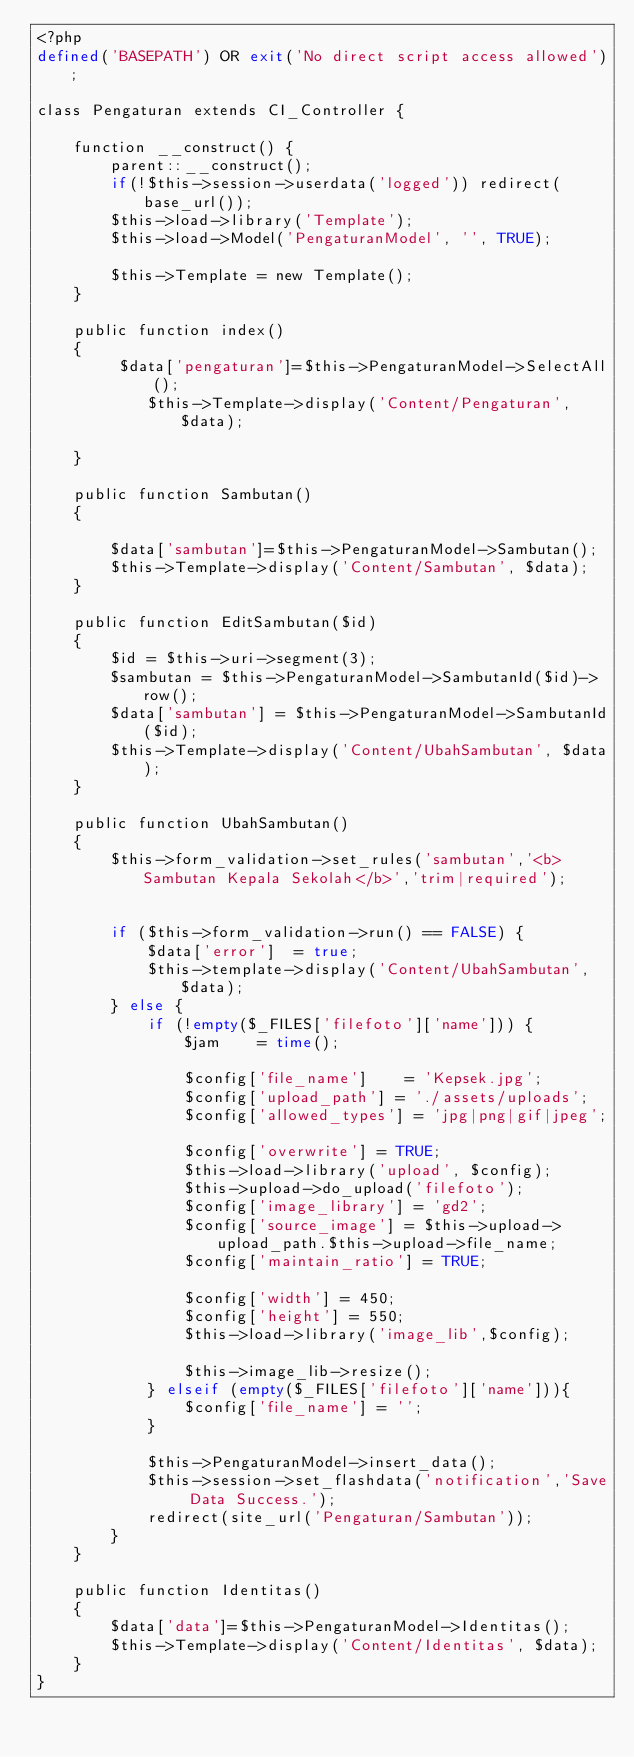Convert code to text. <code><loc_0><loc_0><loc_500><loc_500><_PHP_><?php
defined('BASEPATH') OR exit('No direct script access allowed');

class Pengaturan extends CI_Controller {

	function __construct() {
		parent::__construct(); 
		if(!$this->session->userdata('logged')) redirect(base_url());
		$this->load->library('Template');
		$this->load->Model('PengaturanModel', '', TRUE);
		
		$this->Template = new Template();
	}
	
	public function index()
	{
		 $data['pengaturan']=$this->PengaturanModel->SelectAll();
			$this->Template->display('Content/Pengaturan', $data);
		  
	}
	
	public function Sambutan()
	{
		
		$data['sambutan']=$this->PengaturanModel->Sambutan();
		$this->Template->display('Content/Sambutan', $data);
	}
	
	public function EditSambutan($id)
	{
		$id = $this->uri->segment(3);
		$sambutan = $this->PengaturanModel->SambutanId($id)->row(); 
		$data['sambutan'] = $this->PengaturanModel->SambutanId($id); 
		$this->Template->display('Content/UbahSambutan', $data);
	}
	
	public function UbahSambutan()
	{
		$this->form_validation->set_rules('sambutan','<b>Sambutan Kepala Sekolah</b>','trim|required'); 	

		if ($this->form_validation->run() == FALSE) {
			$data['error']	= true;
			$this->template->display('Content/UbahSambutan', $data);
		} else {
			if (!empty($_FILES['filefoto']['name'])) {
				$jam 	= time(); 
					
				$config['file_name']    = 'Kepsek.jpg';
				$config['upload_path'] = './assets/uploads';
				$config['allowed_types'] = 'jpg|png|gif|jpeg';		
				$config['overwrite'] = TRUE;
				$this->load->library('upload', $config);
				$this->upload->do_upload('filefoto');
				$config['image_library'] = 'gd2';
				$config['source_image'] = $this->upload->upload_path.$this->upload->file_name;
				$config['maintain_ratio'] = TRUE;
												
				$config['width'] = 450;
				$config['height'] = 550;
				$this->load->library('image_lib',$config);
				 
				$this->image_lib->resize();
			} elseif (empty($_FILES['filefoto']['name'])){
				$config['file_name'] = '';
			}

			$this->PengaturanModel->insert_data();
			$this->session->set_flashdata('notification','Save Data Success.');
 			redirect(site_url('Pengaturan/Sambutan'));
		}
	}
	
	public function Identitas()
	{
		$data['data']=$this->PengaturanModel->Identitas();
		$this->Template->display('Content/Identitas', $data);
	}
}
</code> 